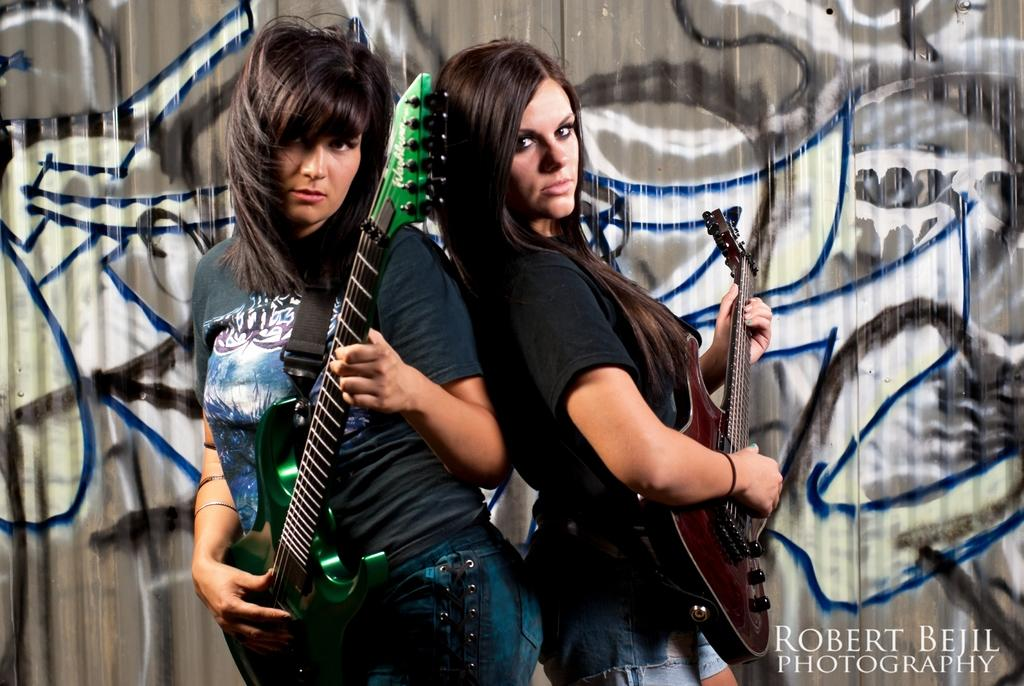How many people are in the image? There are two women in the image. What are the women holding in the image? The women are holding a guitar. Where are the women standing in the image? The women are standing on a stage. What is behind the women in the image? There is a wall behind the women. What can be said about the appearance of the wall? The wall is painted. What type of caption is written on the guitar in the image? There is no caption written on the guitar in the image. Can you see any ducks or tigers in the image? No, there are no ducks or tigers present in the image. 